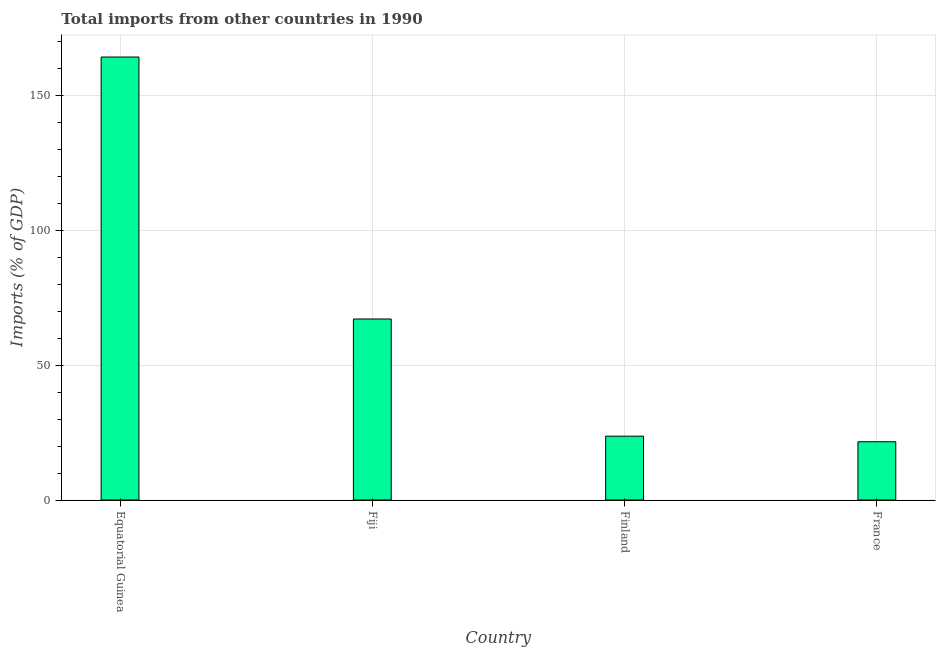Does the graph contain grids?
Your answer should be compact. Yes. What is the title of the graph?
Offer a very short reply. Total imports from other countries in 1990. What is the label or title of the X-axis?
Keep it short and to the point. Country. What is the label or title of the Y-axis?
Your answer should be compact. Imports (% of GDP). What is the total imports in Equatorial Guinea?
Give a very brief answer. 164.35. Across all countries, what is the maximum total imports?
Provide a succinct answer. 164.35. Across all countries, what is the minimum total imports?
Ensure brevity in your answer.  21.61. In which country was the total imports maximum?
Keep it short and to the point. Equatorial Guinea. In which country was the total imports minimum?
Provide a succinct answer. France. What is the sum of the total imports?
Your answer should be very brief. 276.81. What is the difference between the total imports in Equatorial Guinea and Fiji?
Your response must be concise. 97.2. What is the average total imports per country?
Give a very brief answer. 69.2. What is the median total imports?
Make the answer very short. 45.42. In how many countries, is the total imports greater than 150 %?
Make the answer very short. 1. What is the ratio of the total imports in Fiji to that in Finland?
Ensure brevity in your answer.  2.84. Is the total imports in Equatorial Guinea less than that in Fiji?
Offer a terse response. No. Is the difference between the total imports in Fiji and Finland greater than the difference between any two countries?
Give a very brief answer. No. What is the difference between the highest and the second highest total imports?
Ensure brevity in your answer.  97.2. Is the sum of the total imports in Finland and France greater than the maximum total imports across all countries?
Offer a very short reply. No. What is the difference between the highest and the lowest total imports?
Provide a short and direct response. 142.74. In how many countries, is the total imports greater than the average total imports taken over all countries?
Provide a short and direct response. 1. Are all the bars in the graph horizontal?
Make the answer very short. No. How many countries are there in the graph?
Keep it short and to the point. 4. Are the values on the major ticks of Y-axis written in scientific E-notation?
Ensure brevity in your answer.  No. What is the Imports (% of GDP) in Equatorial Guinea?
Offer a terse response. 164.35. What is the Imports (% of GDP) in Fiji?
Your response must be concise. 67.16. What is the Imports (% of GDP) of Finland?
Offer a terse response. 23.68. What is the Imports (% of GDP) of France?
Make the answer very short. 21.61. What is the difference between the Imports (% of GDP) in Equatorial Guinea and Fiji?
Your response must be concise. 97.2. What is the difference between the Imports (% of GDP) in Equatorial Guinea and Finland?
Your answer should be compact. 140.67. What is the difference between the Imports (% of GDP) in Equatorial Guinea and France?
Ensure brevity in your answer.  142.74. What is the difference between the Imports (% of GDP) in Fiji and Finland?
Your response must be concise. 43.47. What is the difference between the Imports (% of GDP) in Fiji and France?
Offer a terse response. 45.54. What is the difference between the Imports (% of GDP) in Finland and France?
Your answer should be compact. 2.07. What is the ratio of the Imports (% of GDP) in Equatorial Guinea to that in Fiji?
Give a very brief answer. 2.45. What is the ratio of the Imports (% of GDP) in Equatorial Guinea to that in Finland?
Provide a succinct answer. 6.94. What is the ratio of the Imports (% of GDP) in Equatorial Guinea to that in France?
Keep it short and to the point. 7.6. What is the ratio of the Imports (% of GDP) in Fiji to that in Finland?
Ensure brevity in your answer.  2.84. What is the ratio of the Imports (% of GDP) in Fiji to that in France?
Ensure brevity in your answer.  3.11. What is the ratio of the Imports (% of GDP) in Finland to that in France?
Give a very brief answer. 1.1. 